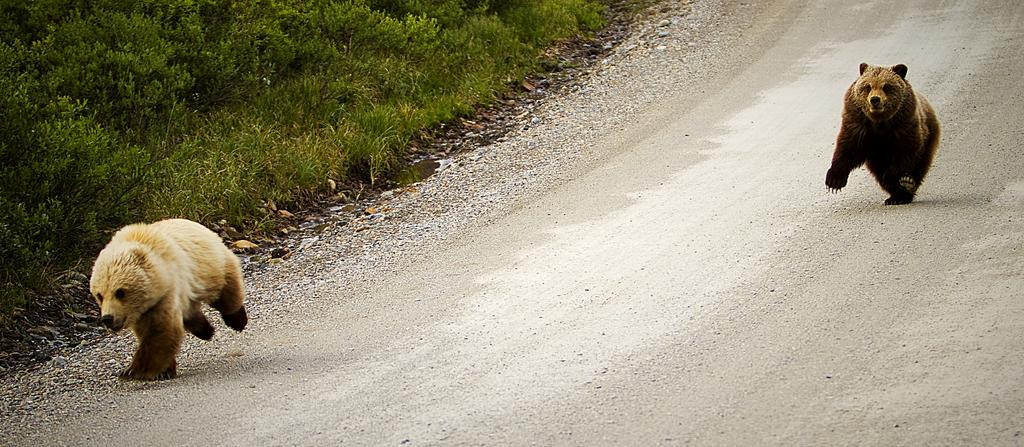How many animals can be seen in the image? There are two animals in the image. What is located at the bottom of the image? There is a road at the bottom of the image. What type of vegetation is on the left side of the image? There are plants on the left side of the image. What type of ground cover is present in the image? There is grass in the image. Where is the sink located in the image? There is no sink present in the image. Can you tell me how many potatoes are visible in the image? There are no potatoes visible in the image. 